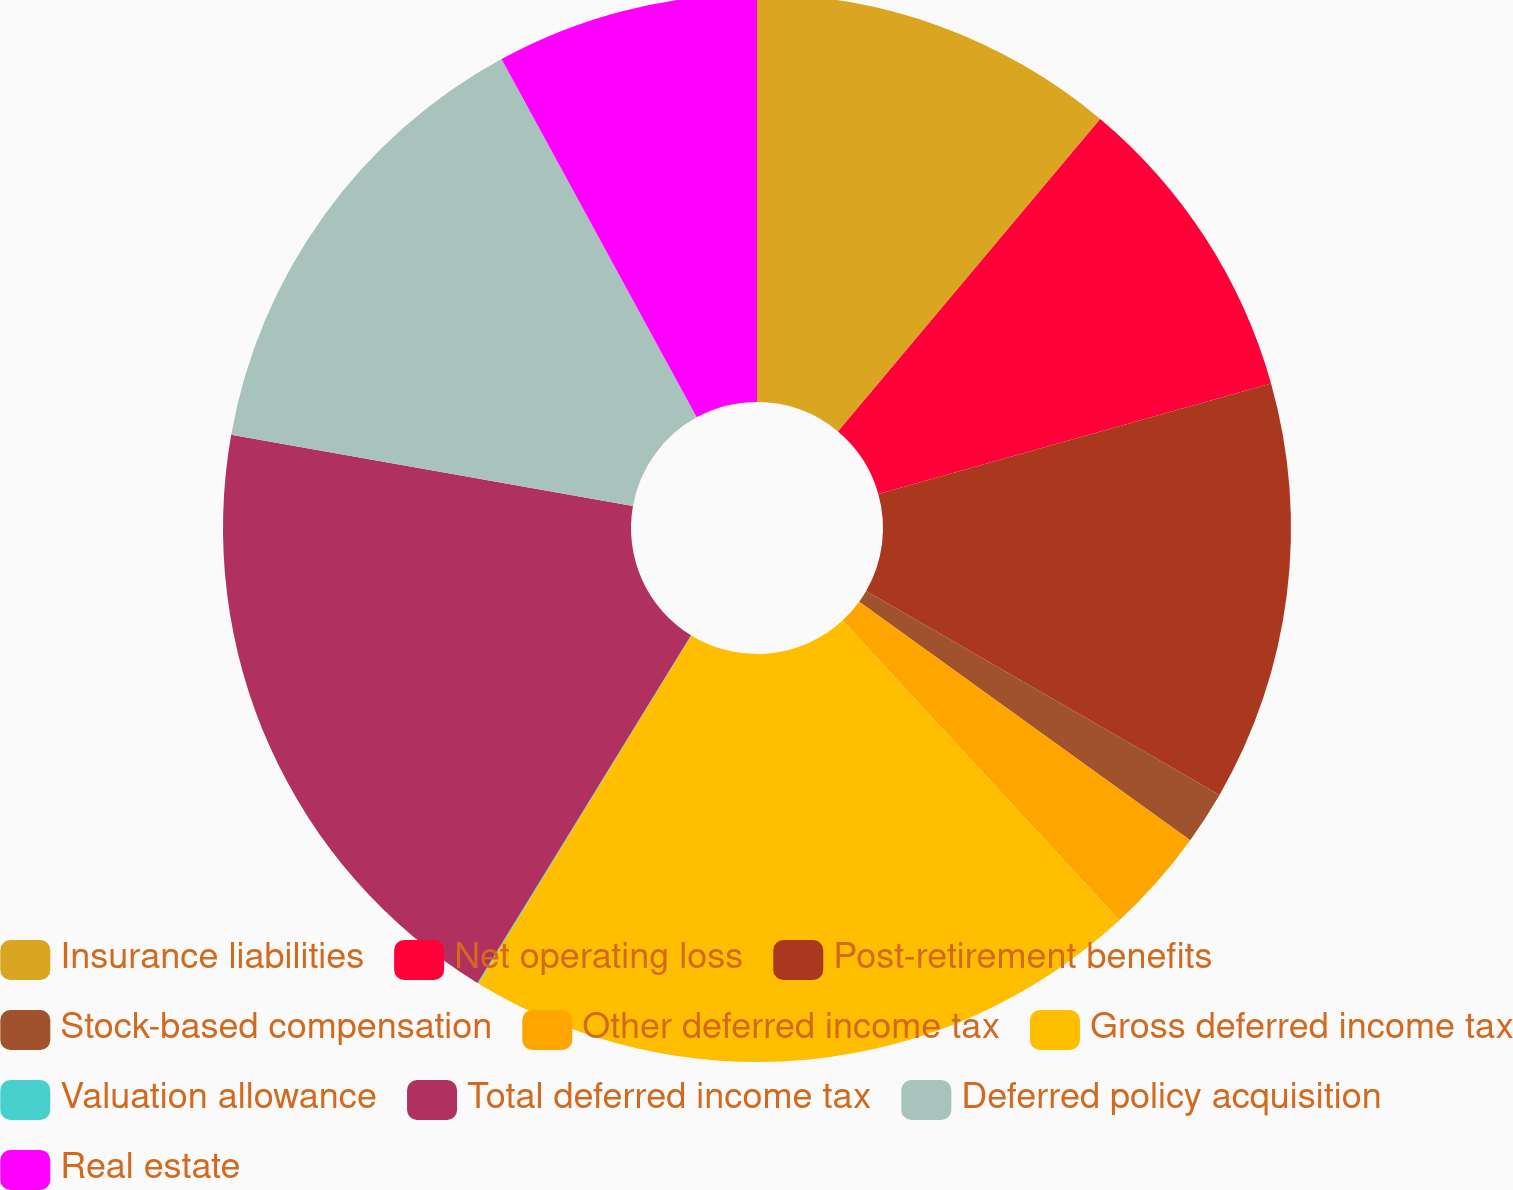<chart> <loc_0><loc_0><loc_500><loc_500><pie_chart><fcel>Insurance liabilities<fcel>Net operating loss<fcel>Post-retirement benefits<fcel>Stock-based compensation<fcel>Other deferred income tax<fcel>Gross deferred income tax<fcel>Valuation allowance<fcel>Total deferred income tax<fcel>Deferred policy acquisition<fcel>Real estate<nl><fcel>11.11%<fcel>9.53%<fcel>12.69%<fcel>1.61%<fcel>3.19%<fcel>20.61%<fcel>0.03%<fcel>19.02%<fcel>14.27%<fcel>7.94%<nl></chart> 